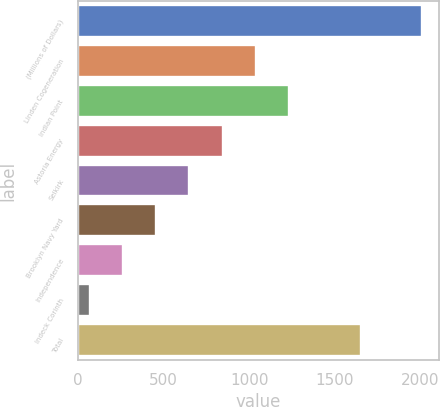Convert chart. <chart><loc_0><loc_0><loc_500><loc_500><bar_chart><fcel>(Millions of Dollars)<fcel>Linden Cogeneration<fcel>Indian Point<fcel>Astoria Energy<fcel>Selkirk<fcel>Brooklyn Navy Yard<fcel>Independence<fcel>Indeck Corinth<fcel>Total<nl><fcel>2010<fcel>1039<fcel>1233.2<fcel>844.8<fcel>650.6<fcel>456.4<fcel>262.2<fcel>68<fcel>1656<nl></chart> 